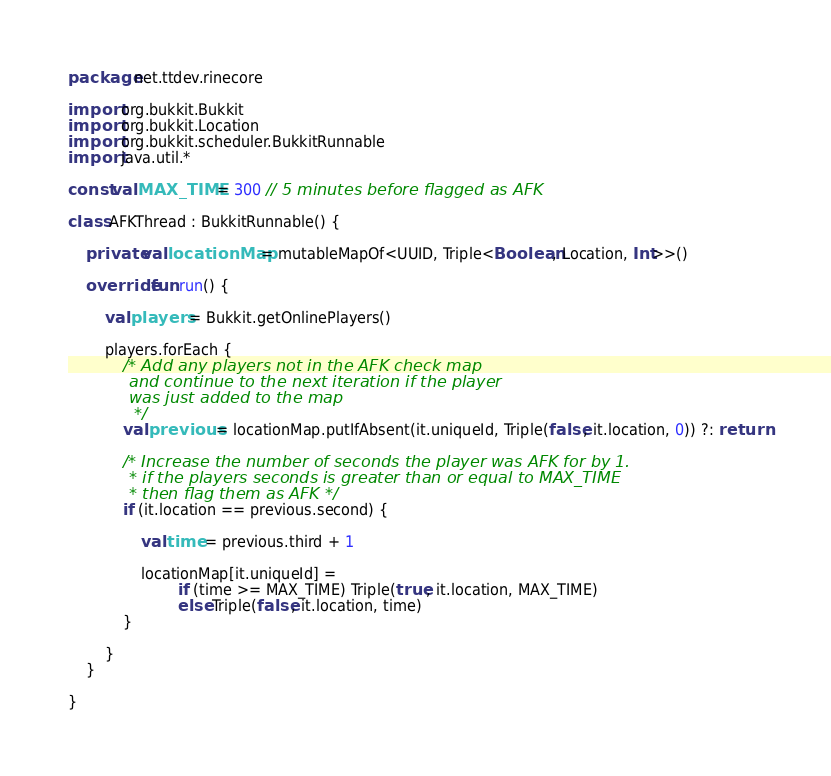Convert code to text. <code><loc_0><loc_0><loc_500><loc_500><_Kotlin_>package net.ttdev.rinecore

import org.bukkit.Bukkit
import org.bukkit.Location
import org.bukkit.scheduler.BukkitRunnable
import java.util.*

const val MAX_TIME = 300 // 5 minutes before flagged as AFK

class AFKThread : BukkitRunnable() {

    private val locationMap = mutableMapOf<UUID, Triple<Boolean, Location, Int>>()

    override fun run() {

        val players = Bukkit.getOnlinePlayers()

        players.forEach {
            /* Add any players not in the AFK check map
            and continue to the next iteration if the player
            was just added to the map
             */
            val previous = locationMap.putIfAbsent(it.uniqueId, Triple(false, it.location, 0)) ?: return

            /* Increase the number of seconds the player was AFK for by 1.
            * if the players seconds is greater than or equal to MAX_TIME
            * then flag them as AFK */
            if (it.location == previous.second) {

                val time = previous.third + 1

                locationMap[it.uniqueId] =
                        if (time >= MAX_TIME) Triple(true, it.location, MAX_TIME)
                        else Triple(false, it.location, time)
            }

        }
    }

}</code> 